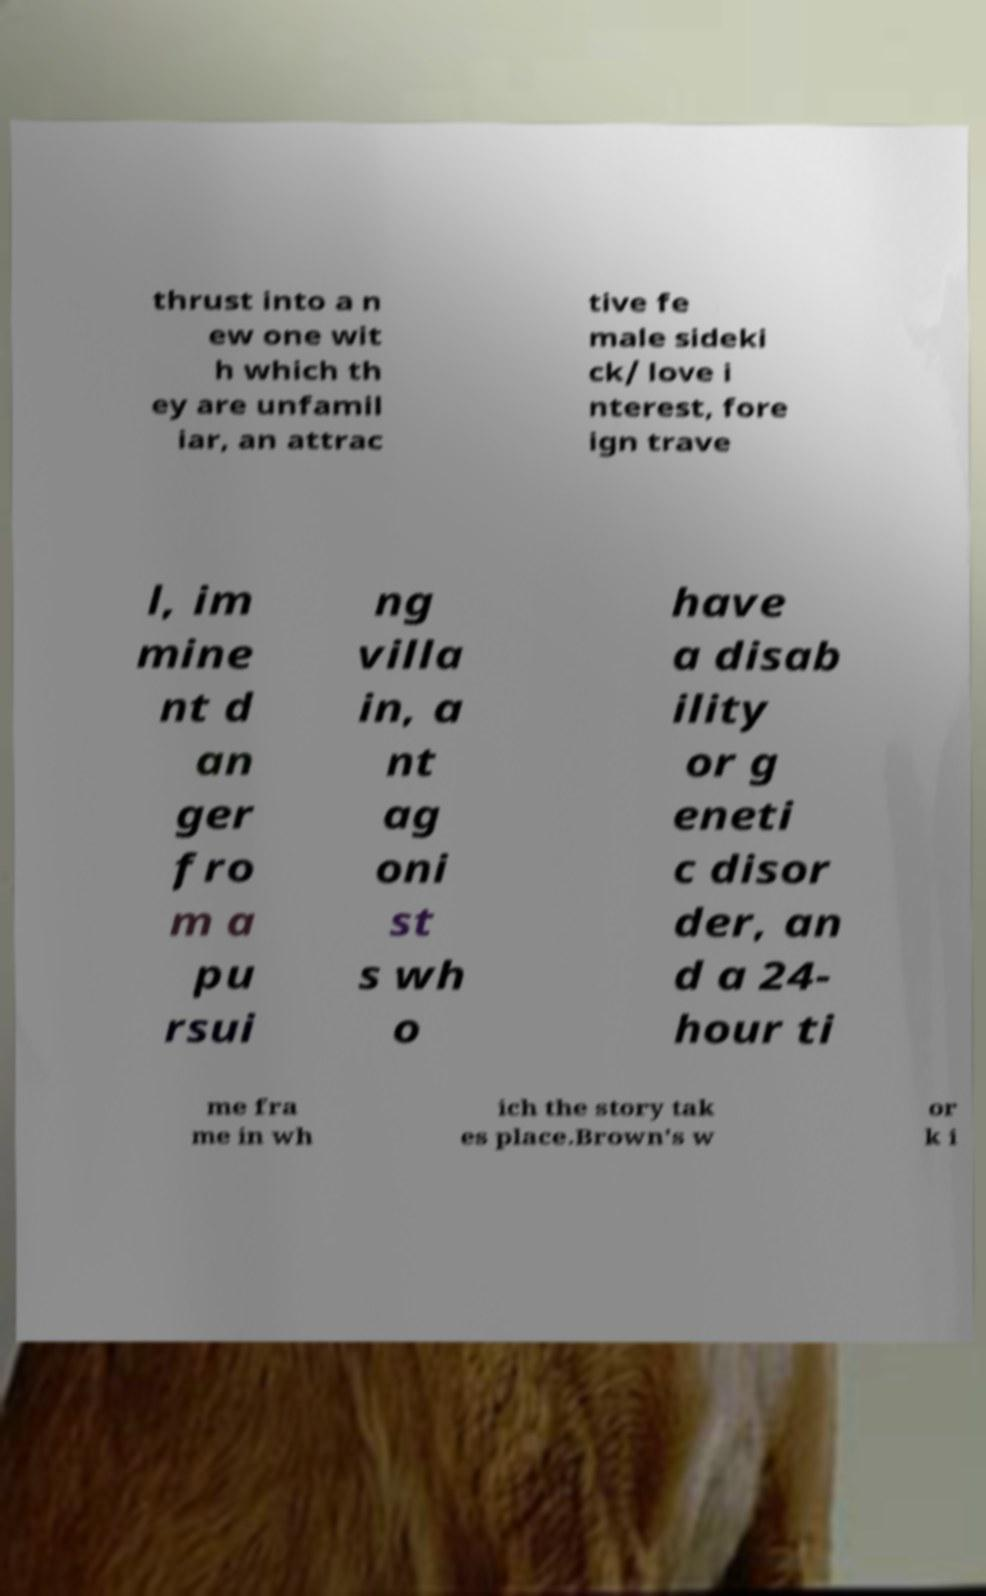I need the written content from this picture converted into text. Can you do that? thrust into a n ew one wit h which th ey are unfamil iar, an attrac tive fe male sideki ck/ love i nterest, fore ign trave l, im mine nt d an ger fro m a pu rsui ng villa in, a nt ag oni st s wh o have a disab ility or g eneti c disor der, an d a 24- hour ti me fra me in wh ich the story tak es place.Brown's w or k i 